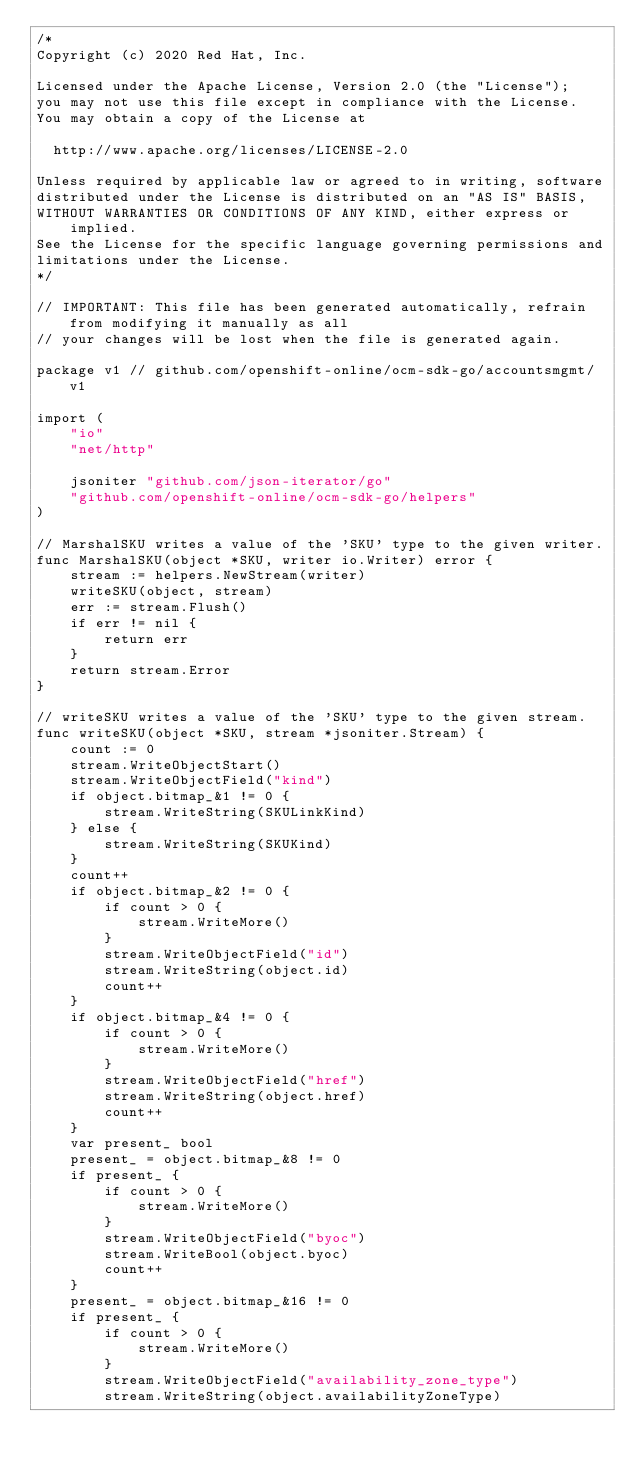Convert code to text. <code><loc_0><loc_0><loc_500><loc_500><_Go_>/*
Copyright (c) 2020 Red Hat, Inc.

Licensed under the Apache License, Version 2.0 (the "License");
you may not use this file except in compliance with the License.
You may obtain a copy of the License at

  http://www.apache.org/licenses/LICENSE-2.0

Unless required by applicable law or agreed to in writing, software
distributed under the License is distributed on an "AS IS" BASIS,
WITHOUT WARRANTIES OR CONDITIONS OF ANY KIND, either express or implied.
See the License for the specific language governing permissions and
limitations under the License.
*/

// IMPORTANT: This file has been generated automatically, refrain from modifying it manually as all
// your changes will be lost when the file is generated again.

package v1 // github.com/openshift-online/ocm-sdk-go/accountsmgmt/v1

import (
	"io"
	"net/http"

	jsoniter "github.com/json-iterator/go"
	"github.com/openshift-online/ocm-sdk-go/helpers"
)

// MarshalSKU writes a value of the 'SKU' type to the given writer.
func MarshalSKU(object *SKU, writer io.Writer) error {
	stream := helpers.NewStream(writer)
	writeSKU(object, stream)
	err := stream.Flush()
	if err != nil {
		return err
	}
	return stream.Error
}

// writeSKU writes a value of the 'SKU' type to the given stream.
func writeSKU(object *SKU, stream *jsoniter.Stream) {
	count := 0
	stream.WriteObjectStart()
	stream.WriteObjectField("kind")
	if object.bitmap_&1 != 0 {
		stream.WriteString(SKULinkKind)
	} else {
		stream.WriteString(SKUKind)
	}
	count++
	if object.bitmap_&2 != 0 {
		if count > 0 {
			stream.WriteMore()
		}
		stream.WriteObjectField("id")
		stream.WriteString(object.id)
		count++
	}
	if object.bitmap_&4 != 0 {
		if count > 0 {
			stream.WriteMore()
		}
		stream.WriteObjectField("href")
		stream.WriteString(object.href)
		count++
	}
	var present_ bool
	present_ = object.bitmap_&8 != 0
	if present_ {
		if count > 0 {
			stream.WriteMore()
		}
		stream.WriteObjectField("byoc")
		stream.WriteBool(object.byoc)
		count++
	}
	present_ = object.bitmap_&16 != 0
	if present_ {
		if count > 0 {
			stream.WriteMore()
		}
		stream.WriteObjectField("availability_zone_type")
		stream.WriteString(object.availabilityZoneType)</code> 